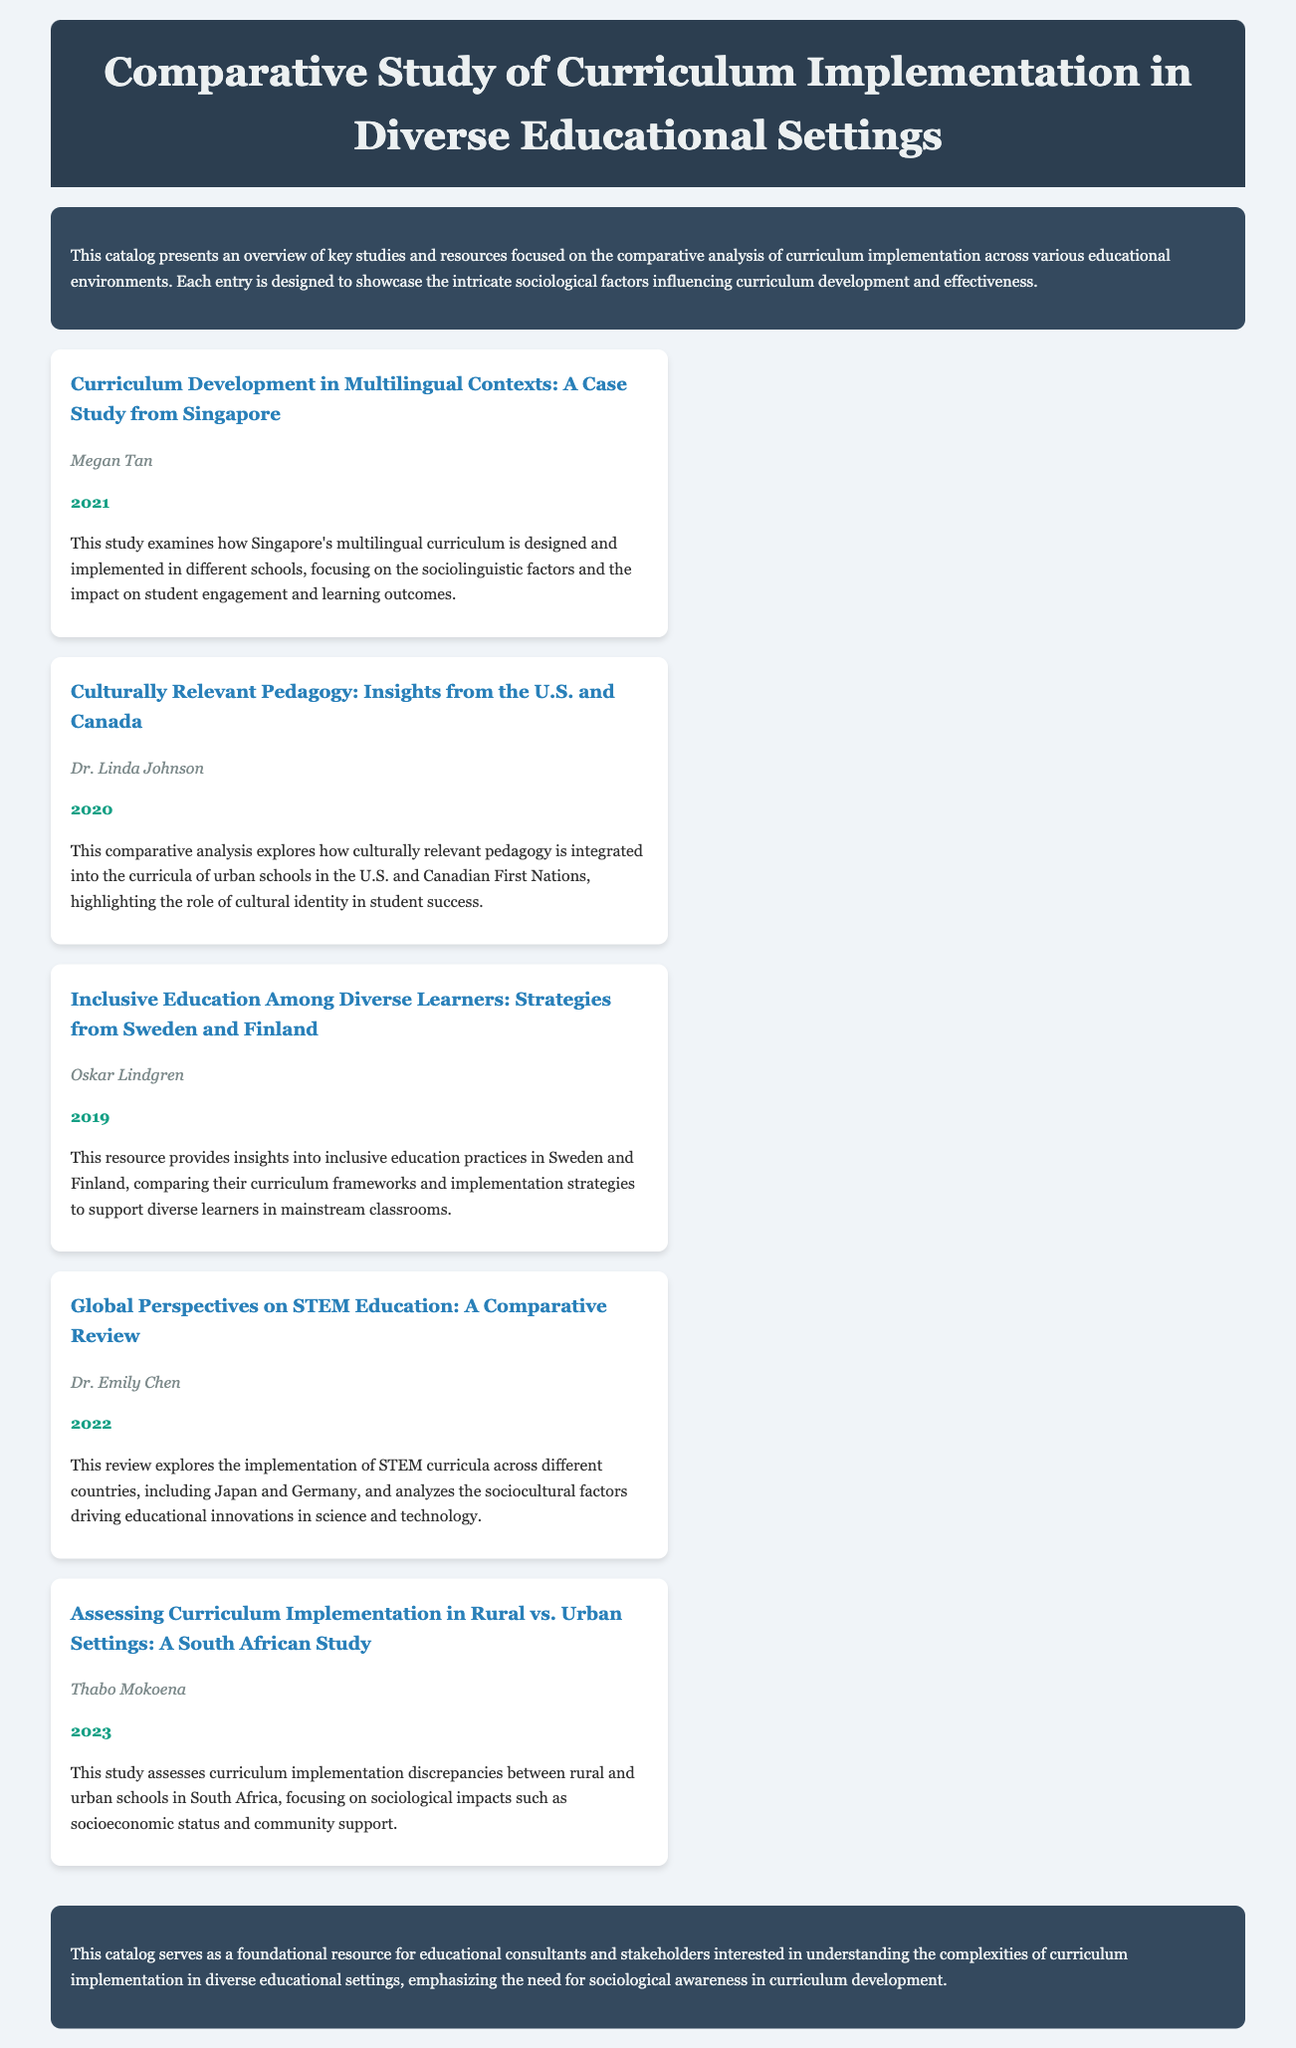What is the title of the catalog? The title of the catalog is provided in the header section of the document.
Answer: Comparative Study of Curriculum Implementation in Diverse Educational Settings Who is the author of the study on multilingual contexts? The study on multilingual contexts includes the author's name listed at the end of the entry.
Answer: Megan Tan In what year was the study on inclusive education published? The year of publication for the inclusive education study is mentioned alongside the author's name.
Answer: 2019 Which countries are compared in the STEM education review? The document lists the countries compared in the global perspectives on STEM education section.
Answer: Japan and Germany What sociological impact does the South African study focus on? The South African study highlights specific sociological factors affecting curriculum implementation.
Answer: Socioeconomic status What is the main focus of Dr. Linda Johnson's study? The focus of Dr. Linda Johnson's study can be inferred from the description in the entry.
Answer: Culturally relevant pedagogy How does the catalog contribute to educational consultants? The conclusion section discusses the value of the catalog for a specific audience.
Answer: Understanding the complexities of curriculum implementation What is the predominant theme across the entries in this catalog? The entries collectively emphasize a common aspect related to curriculum and sociology.
Answer: Sociological factors How many entries are listed in the catalog? The total number of entries is counted based on how many are presented in the entries section.
Answer: Five 